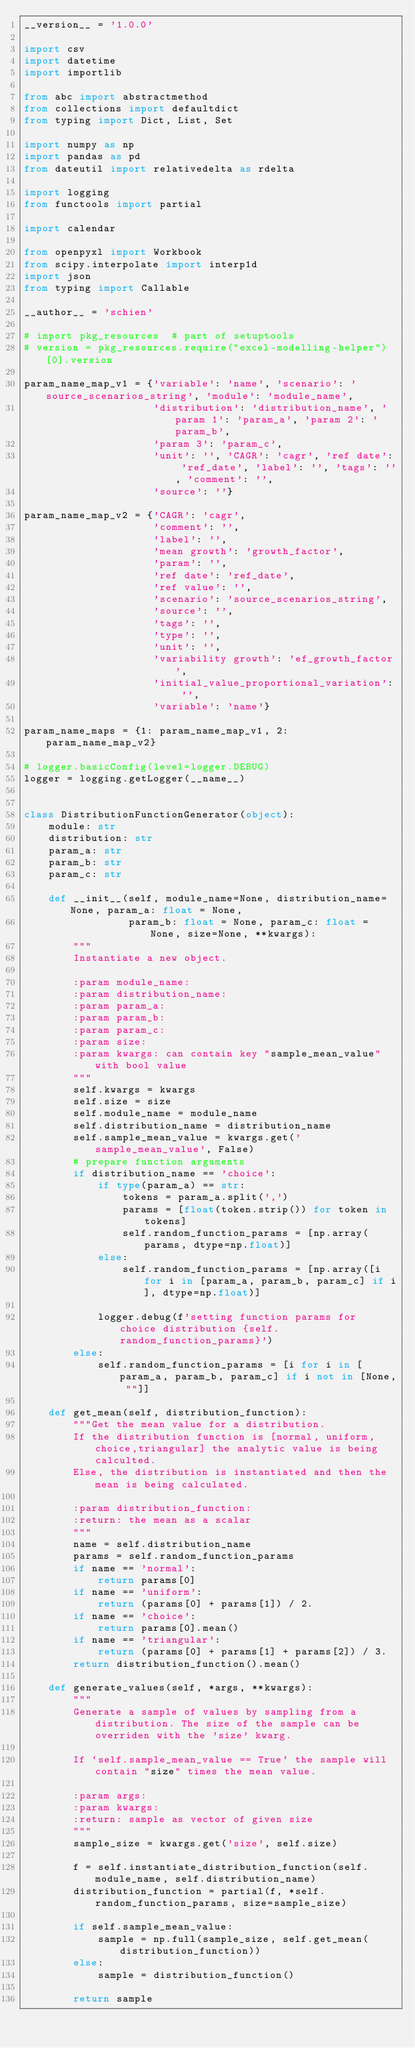Convert code to text. <code><loc_0><loc_0><loc_500><loc_500><_Python_>__version__ = '1.0.0'

import csv
import datetime
import importlib

from abc import abstractmethod
from collections import defaultdict
from typing import Dict, List, Set

import numpy as np
import pandas as pd
from dateutil import relativedelta as rdelta

import logging
from functools import partial

import calendar

from openpyxl import Workbook
from scipy.interpolate import interp1d
import json
from typing import Callable

__author__ = 'schien'

# import pkg_resources  # part of setuptools
# version = pkg_resources.require("excel-modelling-helper")[0].version

param_name_map_v1 = {'variable': 'name', 'scenario': 'source_scenarios_string', 'module': 'module_name',
                     'distribution': 'distribution_name', 'param 1': 'param_a', 'param 2': 'param_b',
                     'param 3': 'param_c',
                     'unit': '', 'CAGR': 'cagr', 'ref date': 'ref_date', 'label': '', 'tags': '', 'comment': '',
                     'source': ''}

param_name_map_v2 = {'CAGR': 'cagr',
                     'comment': '',
                     'label': '',
                     'mean growth': 'growth_factor',
                     'param': '',
                     'ref date': 'ref_date',
                     'ref value': '',
                     'scenario': 'source_scenarios_string',
                     'source': '',
                     'tags': '',
                     'type': '',
                     'unit': '',
                     'variability growth': 'ef_growth_factor',
                     'initial_value_proportional_variation': '',
                     'variable': 'name'}

param_name_maps = {1: param_name_map_v1, 2: param_name_map_v2}

# logger.basicConfig(level=logger.DEBUG)
logger = logging.getLogger(__name__)


class DistributionFunctionGenerator(object):
    module: str
    distribution: str
    param_a: str
    param_b: str
    param_c: str

    def __init__(self, module_name=None, distribution_name=None, param_a: float = None,
                 param_b: float = None, param_c: float = None, size=None, **kwargs):
        """
        Instantiate a new object.

        :param module_name:
        :param distribution_name:
        :param param_a:
        :param param_b:
        :param param_c:
        :param size:
        :param kwargs: can contain key "sample_mean_value" with bool value
        """
        self.kwargs = kwargs
        self.size = size
        self.module_name = module_name
        self.distribution_name = distribution_name
        self.sample_mean_value = kwargs.get('sample_mean_value', False)
        # prepare function arguments
        if distribution_name == 'choice':
            if type(param_a) == str:
                tokens = param_a.split(',')
                params = [float(token.strip()) for token in tokens]
                self.random_function_params = [np.array(params, dtype=np.float)]
            else:
                self.random_function_params = [np.array([i for i in [param_a, param_b, param_c] if i], dtype=np.float)]

            logger.debug(f'setting function params for choice distribution {self.random_function_params}')
        else:
            self.random_function_params = [i for i in [param_a, param_b, param_c] if i not in [None, ""]]

    def get_mean(self, distribution_function):
        """Get the mean value for a distribution.
        If the distribution function is [normal, uniform,choice,triangular] the analytic value is being calculted.
        Else, the distribution is instantiated and then the mean is being calculated.

        :param distribution_function:
        :return: the mean as a scalar
        """
        name = self.distribution_name
        params = self.random_function_params
        if name == 'normal':
            return params[0]
        if name == 'uniform':
            return (params[0] + params[1]) / 2.
        if name == 'choice':
            return params[0].mean()
        if name == 'triangular':
            return (params[0] + params[1] + params[2]) / 3.
        return distribution_function().mean()

    def generate_values(self, *args, **kwargs):
        """
        Generate a sample of values by sampling from a distribution. The size of the sample can be overriden with the 'size' kwarg.

        If `self.sample_mean_value == True` the sample will contain "size" times the mean value.

        :param args:
        :param kwargs:
        :return: sample as vector of given size
        """
        sample_size = kwargs.get('size', self.size)

        f = self.instantiate_distribution_function(self.module_name, self.distribution_name)
        distribution_function = partial(f, *self.random_function_params, size=sample_size)

        if self.sample_mean_value:
            sample = np.full(sample_size, self.get_mean(distribution_function))
        else:
            sample = distribution_function()

        return sample
</code> 